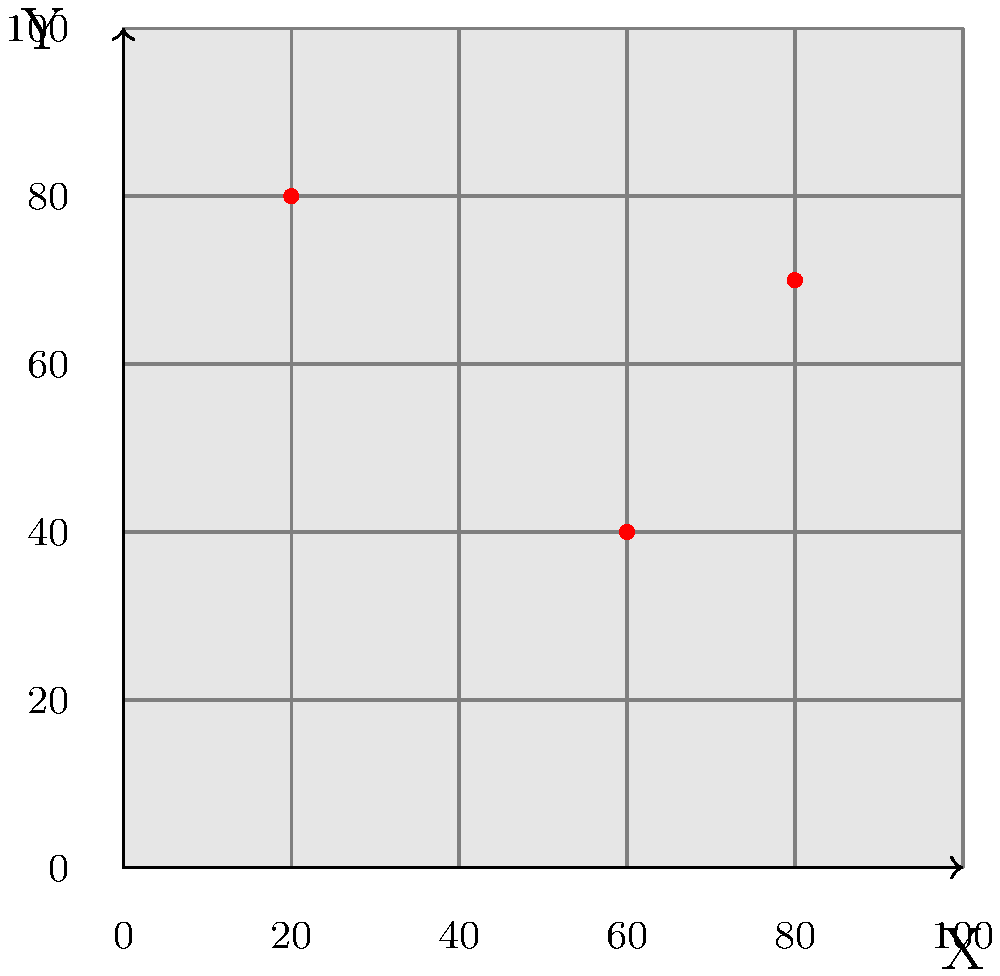Given the coordinate grid overlaid on a map representing a region, three points of significant cult influence have been identified and marked in red. If the coordinates of these points are (20, 80), (60, 40), and (80, 70), what is the area of the triangle formed by connecting these three points? Express your answer in square units. To find the area of the triangle formed by the three points of cult influence, we can use the formula for the area of a triangle given the coordinates of its vertices. The formula is:

$$A = \frac{1}{2}|x_1(y_2 - y_3) + x_2(y_3 - y_1) + x_3(y_1 - y_2)|$$

Where $(x_1, y_1)$, $(x_2, y_2)$, and $(x_3, y_3)$ are the coordinates of the three vertices.

Let's assign the points as follows:
$(x_1, y_1) = (20, 80)$
$(x_2, y_2) = (60, 40)$
$(x_3, y_3) = (80, 70)$

Now, let's substitute these values into the formula:

$$A = \frac{1}{2}|20(40 - 70) + 60(70 - 80) + 80(80 - 40)|$$

$$A = \frac{1}{2}|20(-30) + 60(-10) + 80(40)|$$

$$A = \frac{1}{2}|-600 - 600 + 3200|$$

$$A = \frac{1}{2}|2000|$$

$$A = \frac{1}{2}(2000)$$

$$A = 1000$$

Therefore, the area of the triangle is 1000 square units.
Answer: 1000 square units 